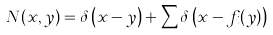Convert formula to latex. <formula><loc_0><loc_0><loc_500><loc_500>N ( x , y ) = \delta \left ( x - y \right ) + \sum \delta \left ( x - f _ { i } ( y ) \right )</formula> 